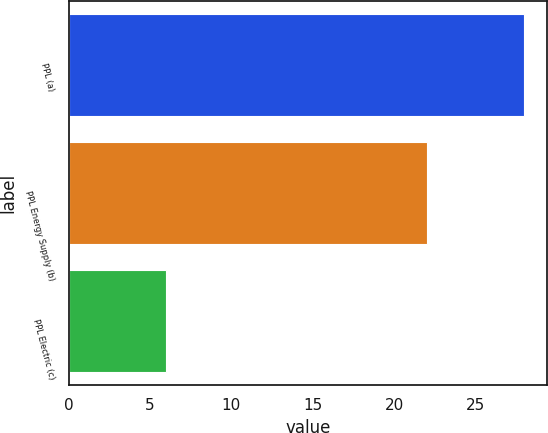Convert chart to OTSL. <chart><loc_0><loc_0><loc_500><loc_500><bar_chart><fcel>PPL (a)<fcel>PPL Energy Supply (b)<fcel>PPL Electric (c)<nl><fcel>28<fcel>22<fcel>6<nl></chart> 